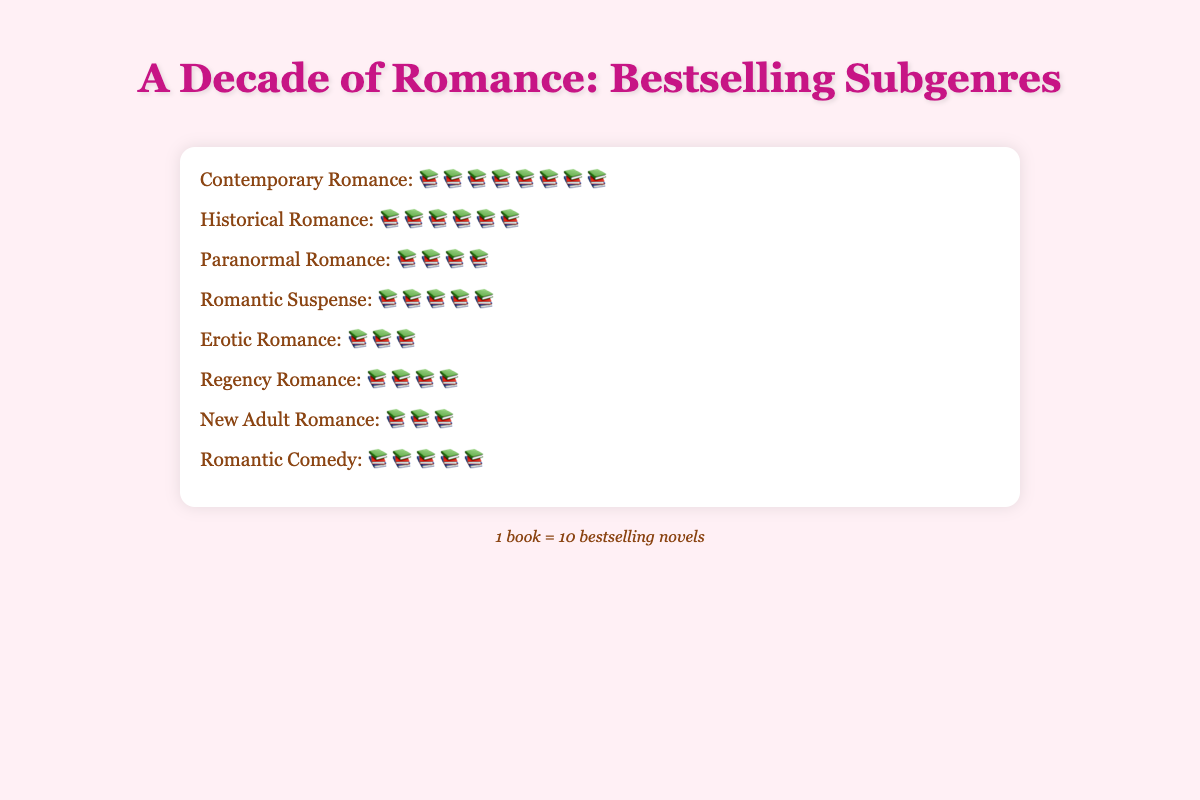What title is displayed at the top of the figure? The title is written in a prominent font at the top center of the figure. It reads "A Decade of Romance: Bestselling Subgenres".
Answer: A Decade of Romance: Bestselling Subgenres Which subgenre has the highest number of books? By visually counting the icons, the subgenre with the most books is "Contemporary Romance" with 8 books.
Answer: Contemporary Romance How many more bestselling novels does "Historical Romance" have compared to "Erotic Romance"? "Historical Romance" has 6 books and "Erotic Romance" has 3 books. The difference in the number of books is 6 - 3 = 3.
Answer: 3 Which two subgenres have the same number of bestselling novels? By observing the number of icons for each subgenre, "Paranormal Romance" and "Regency Romance" both have 4 books each, and "Romantic Suspense" and "Romantic Comedy" both have 5 books each.
Answer: Paranormal Romance and Regency Romance, Romantic Suspense and Romantic Comedy What is the total number of bestselling novels represented in the figure? Summing the number of books for each subgenre: 8 (Contemporary) + 6 (Historical) + 4 (Paranormal) + 5 (Suspense) + 3 (Erotic) + 4 (Regency) + 3 (New Adult) + 5 (Comedy) = 38 units. Each unit represents 10 books, so the total is 38 x 10 = 380 bestselling novels.
Answer: 380 Which subgenres have fewer books than "Romantic Suspense"? "Romantic Suspense" has 5 books. Subgenres with fewer books are: "Paranormal Romance" (4 books), "Erotic Romance" (3 books), "Regency Romance" (4 books), and "New Adult Romance" (3 books).
Answer: Paranormal Romance, Erotic Romance, Regency Romance, New Adult Romance If each icon represents 10 bestselling novels, how many bestselling novels are accounted for by "New Adult Romance" and "Erotic Romance" combined? "New Adult Romance" has 3 books and "Erotic Romance" also has 3 books. Combined, they have 3 + 3 = 6 units. Since each unit represents 10 books, the total number of bestselling novels is 6 x 10 = 60.
Answer: 60 How many unique subgenres are featured in the figure? Counting the distinct categories provided: Contemporary Romance, Historical Romance, Paranormal Romance, Romantic Suspense, Erotic Romance, Regency Romance, New Adult Romance, and Romantic Comedy, there are a total of 8 unique subgenres.
Answer: 8 Which subgenre has the same number of bestselling novels as "Regency Romance"? Both "Paranormal Romance" and "Regency Romance" have 4 books each.
Answer: Paranormal Romance 